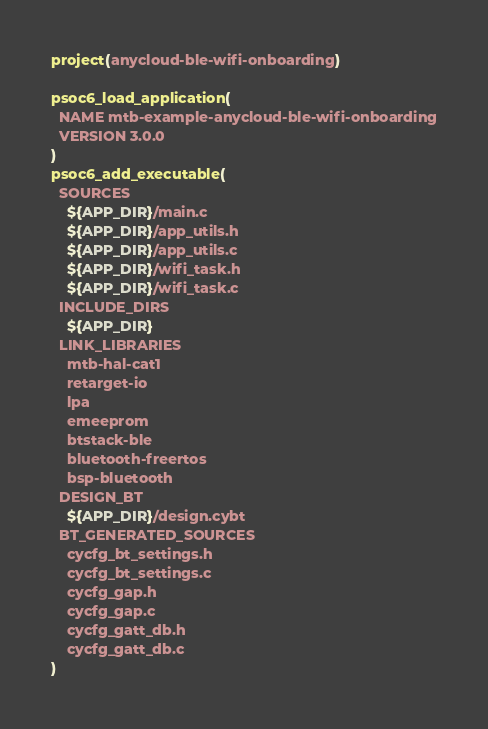Convert code to text. <code><loc_0><loc_0><loc_500><loc_500><_CMake_>project(anycloud-ble-wifi-onboarding)

psoc6_load_application(
  NAME mtb-example-anycloud-ble-wifi-onboarding
  VERSION 3.0.0
)
psoc6_add_executable(
  SOURCES
    ${APP_DIR}/main.c
    ${APP_DIR}/app_utils.h
    ${APP_DIR}/app_utils.c
    ${APP_DIR}/wifi_task.h
    ${APP_DIR}/wifi_task.c
  INCLUDE_DIRS
    ${APP_DIR}
  LINK_LIBRARIES
    mtb-hal-cat1
    retarget-io
    lpa
    emeeprom
    btstack-ble
    bluetooth-freertos
    bsp-bluetooth
  DESIGN_BT
    ${APP_DIR}/design.cybt
  BT_GENERATED_SOURCES
    cycfg_bt_settings.h
    cycfg_bt_settings.c
    cycfg_gap.h
    cycfg_gap.c
    cycfg_gatt_db.h
    cycfg_gatt_db.c
)
</code> 